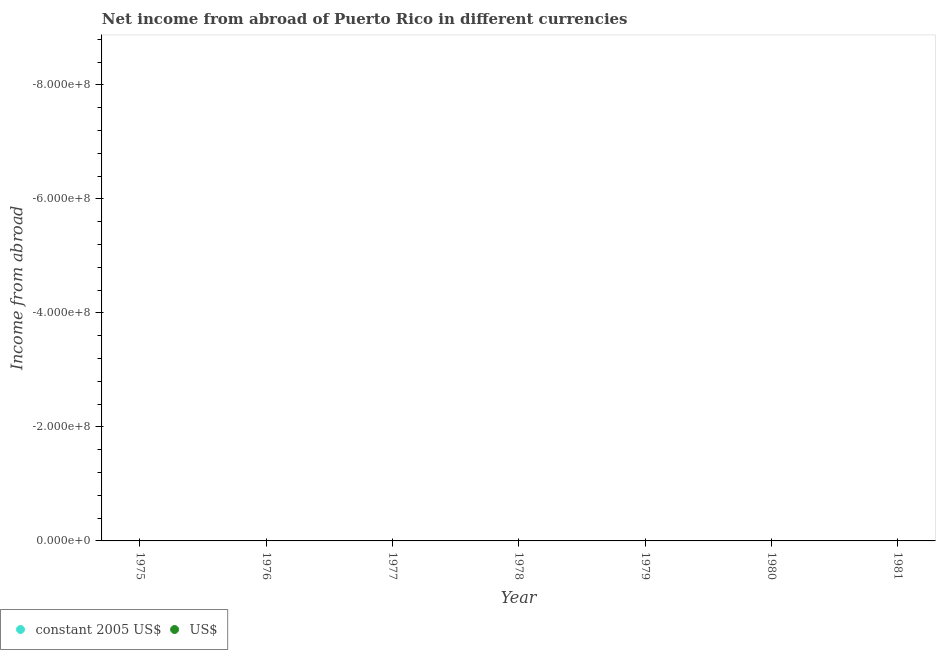How many different coloured dotlines are there?
Provide a succinct answer. 0. Is the number of dotlines equal to the number of legend labels?
Your answer should be very brief. No. What is the income from abroad in us$ in 1975?
Your answer should be compact. 0. Across all years, what is the minimum income from abroad in us$?
Make the answer very short. 0. What is the total income from abroad in us$ in the graph?
Provide a short and direct response. 0. What is the difference between the income from abroad in us$ in 1978 and the income from abroad in constant 2005 us$ in 1977?
Your answer should be very brief. 0. In how many years, is the income from abroad in us$ greater than -320000000 units?
Your response must be concise. 0. In how many years, is the income from abroad in us$ greater than the average income from abroad in us$ taken over all years?
Provide a short and direct response. 0. Is the income from abroad in constant 2005 us$ strictly greater than the income from abroad in us$ over the years?
Make the answer very short. No. Is the income from abroad in us$ strictly less than the income from abroad in constant 2005 us$ over the years?
Your answer should be very brief. No. What is the difference between two consecutive major ticks on the Y-axis?
Provide a succinct answer. 2.00e+08. How are the legend labels stacked?
Ensure brevity in your answer.  Horizontal. What is the title of the graph?
Provide a succinct answer. Net income from abroad of Puerto Rico in different currencies. Does "Public funds" appear as one of the legend labels in the graph?
Offer a very short reply. No. What is the label or title of the Y-axis?
Ensure brevity in your answer.  Income from abroad. What is the Income from abroad of constant 2005 US$ in 1975?
Give a very brief answer. 0. What is the Income from abroad in constant 2005 US$ in 1976?
Give a very brief answer. 0. What is the Income from abroad in US$ in 1976?
Provide a short and direct response. 0. What is the Income from abroad in constant 2005 US$ in 1977?
Give a very brief answer. 0. What is the Income from abroad in constant 2005 US$ in 1978?
Keep it short and to the point. 0. What is the Income from abroad of US$ in 1979?
Provide a short and direct response. 0. What is the Income from abroad in US$ in 1980?
Ensure brevity in your answer.  0. What is the total Income from abroad in US$ in the graph?
Provide a succinct answer. 0. 